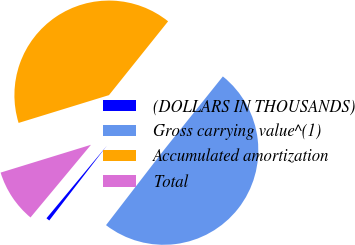<chart> <loc_0><loc_0><loc_500><loc_500><pie_chart><fcel>(DOLLARS IN THOUSANDS)<fcel>Gross carrying value^(1)<fcel>Accumulated amortization<fcel>Total<nl><fcel>0.6%<fcel>49.7%<fcel>40.5%<fcel>9.2%<nl></chart> 